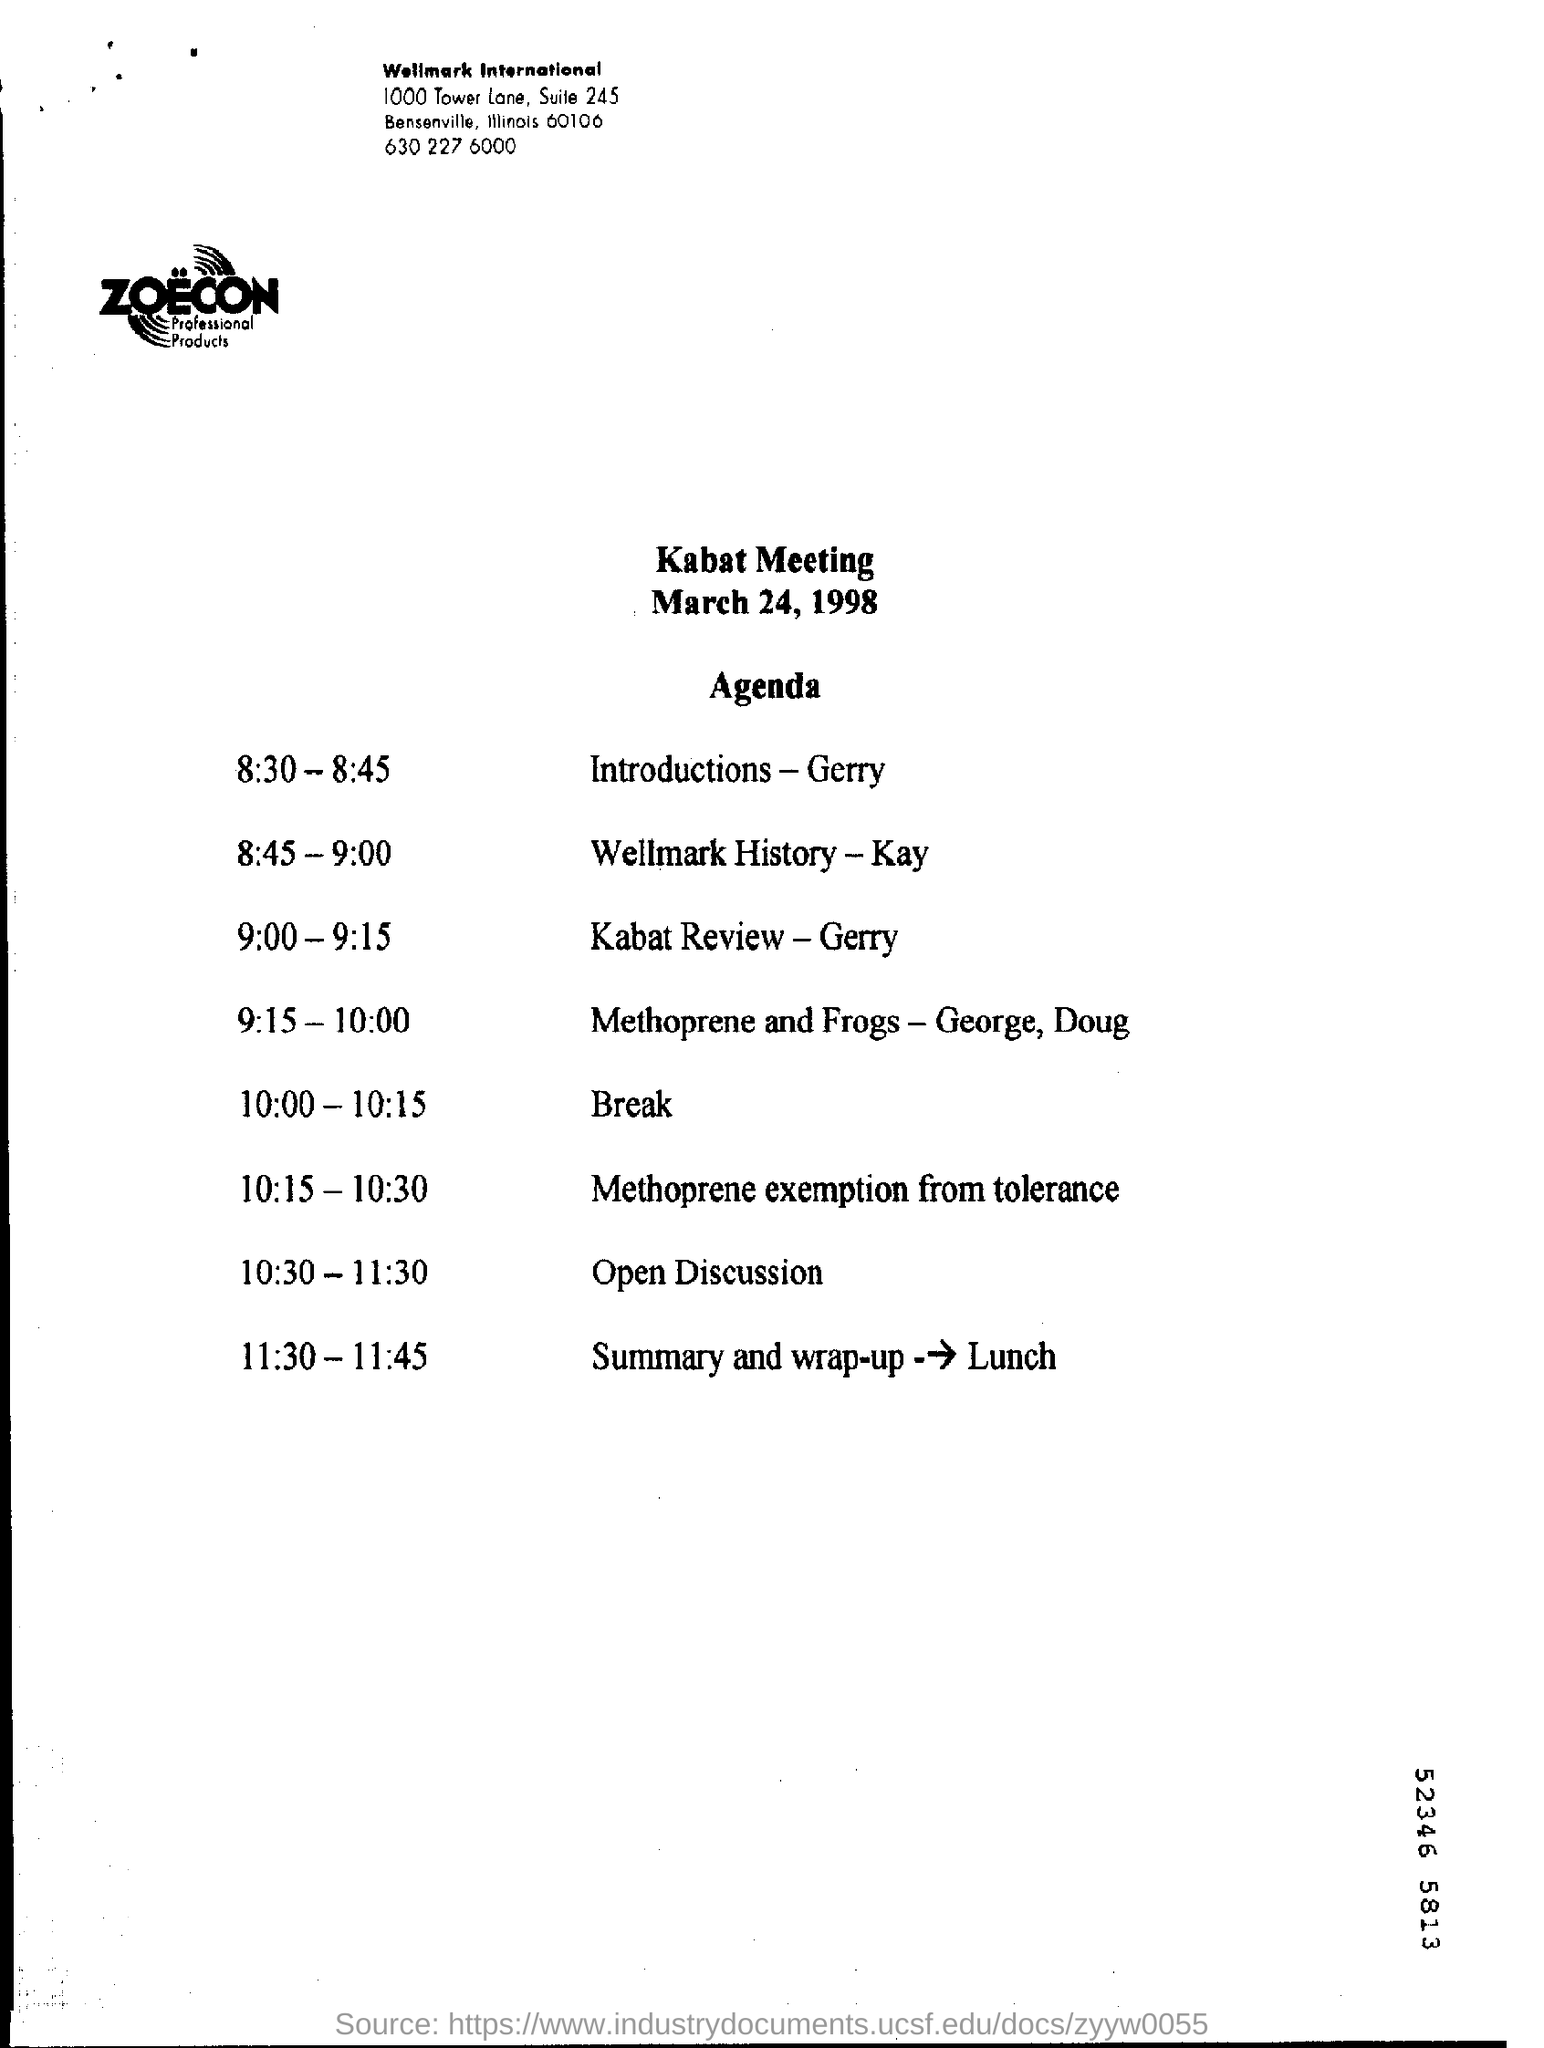Outline some significant characteristics in this image. The Kabat Meeting is scheduled for March 24, 1998. This is a Kabat Meeting. 